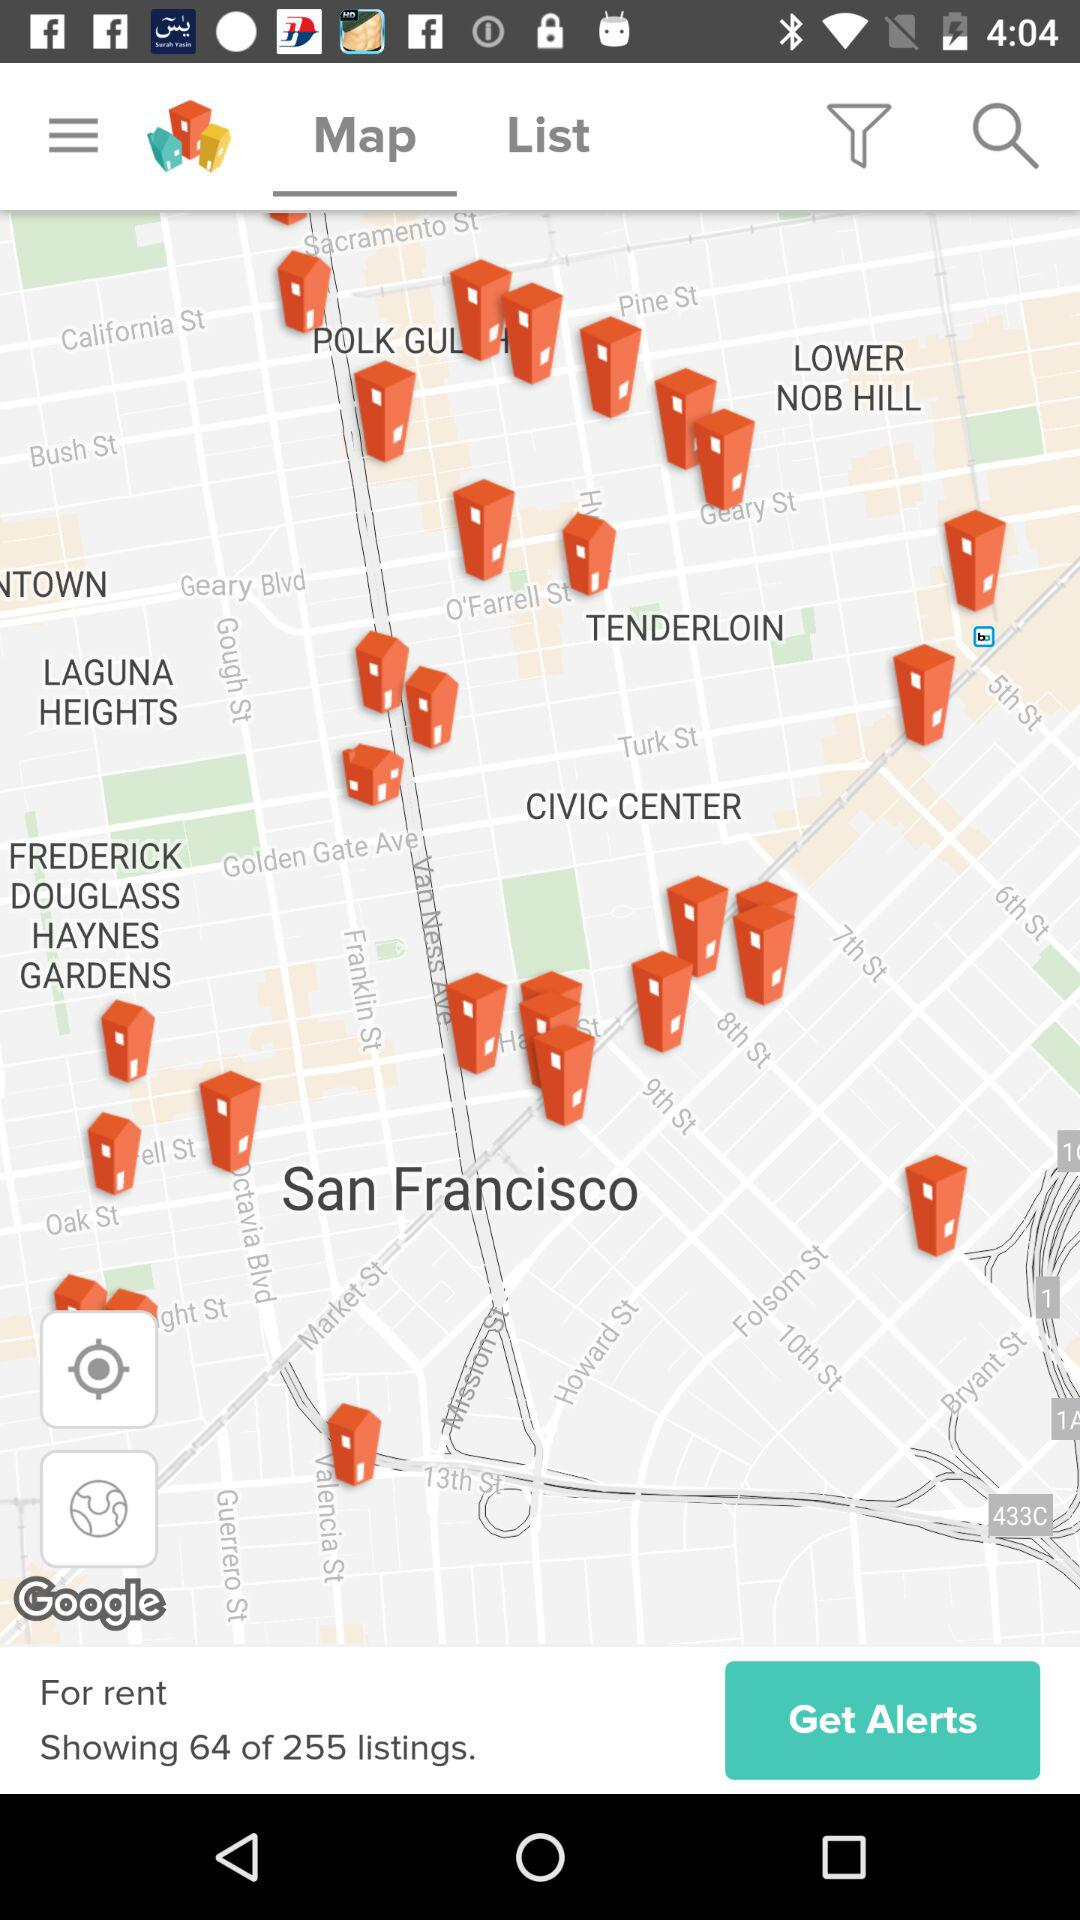What is the total number of listings for rent? The total number of listings for rent is 255. 